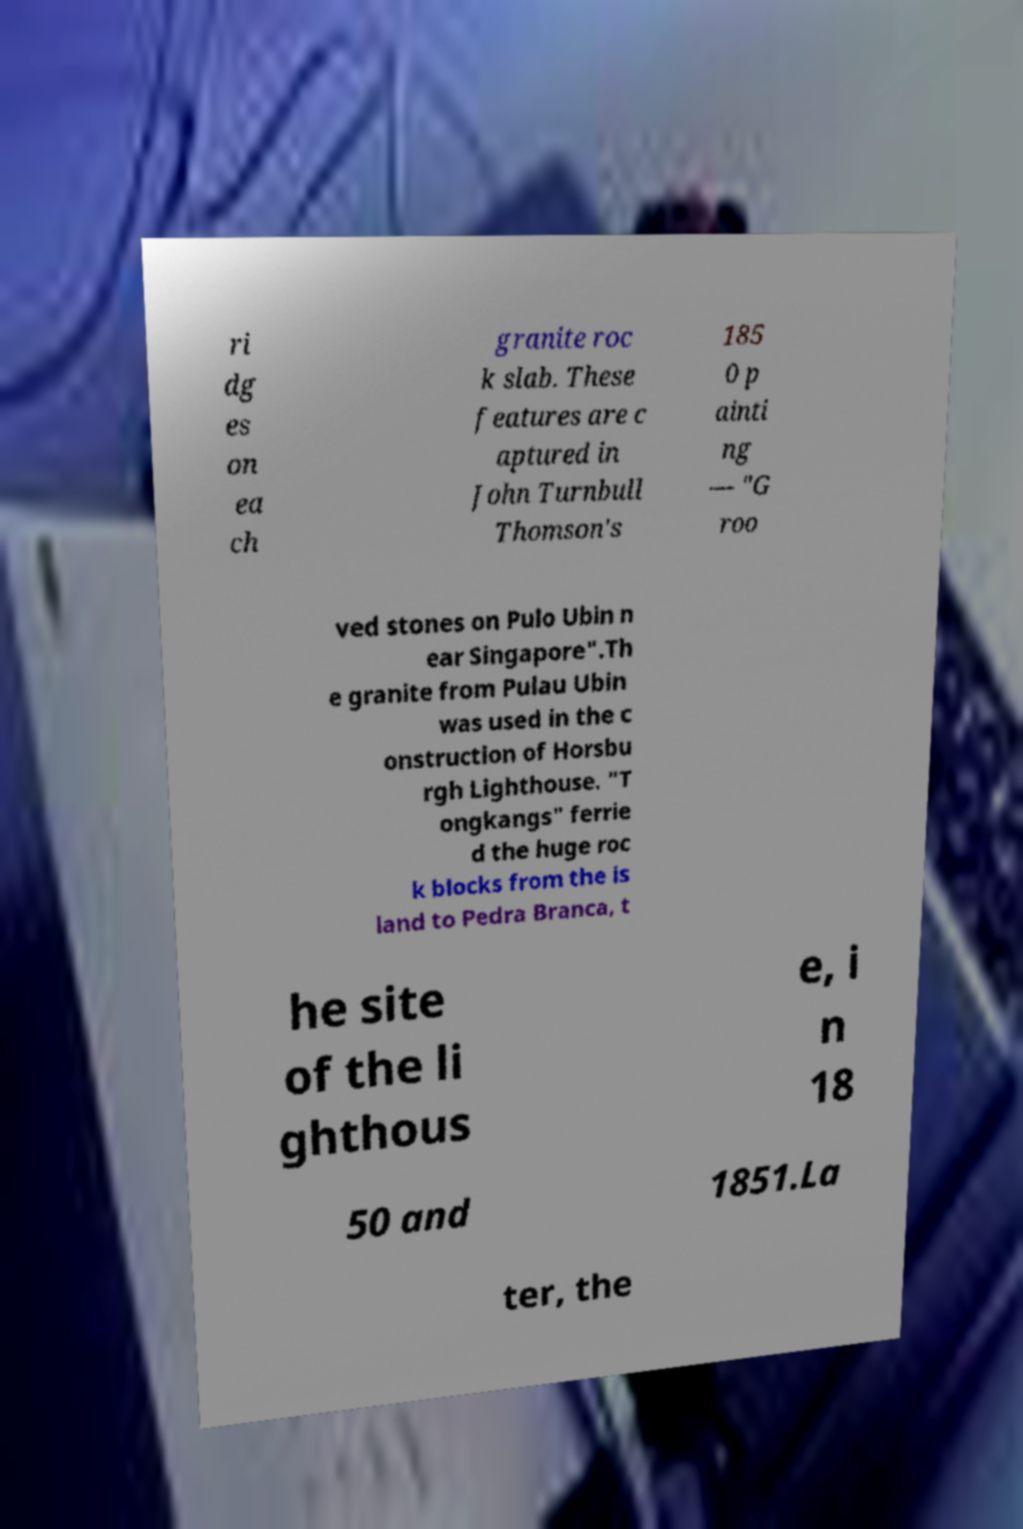Please read and relay the text visible in this image. What does it say? ri dg es on ea ch granite roc k slab. These features are c aptured in John Turnbull Thomson's 185 0 p ainti ng — "G roo ved stones on Pulo Ubin n ear Singapore".Th e granite from Pulau Ubin was used in the c onstruction of Horsbu rgh Lighthouse. "T ongkangs" ferrie d the huge roc k blocks from the is land to Pedra Branca, t he site of the li ghthous e, i n 18 50 and 1851.La ter, the 